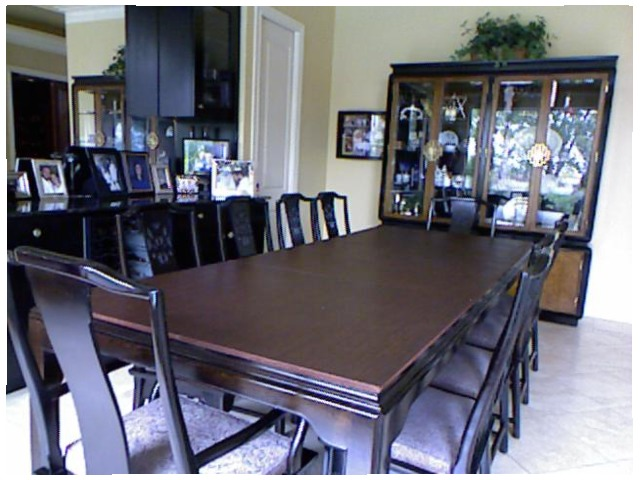<image>
Can you confirm if the chair is on the table? No. The chair is not positioned on the table. They may be near each other, but the chair is not supported by or resting on top of the table. Is there a table behind the chair? No. The table is not behind the chair. From this viewpoint, the table appears to be positioned elsewhere in the scene. Is there a chair behind the table? No. The chair is not behind the table. From this viewpoint, the chair appears to be positioned elsewhere in the scene. Is the chair to the right of the chair? Yes. From this viewpoint, the chair is positioned to the right side relative to the chair. Is there a picture to the right of the door? Yes. From this viewpoint, the picture is positioned to the right side relative to the door. 